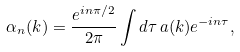Convert formula to latex. <formula><loc_0><loc_0><loc_500><loc_500>\alpha _ { n } ( k ) = \frac { e ^ { i n \pi / 2 } } { 2 \pi } \int { d \tau \, a ( { k } ) e ^ { - i n \tau } } ,</formula> 